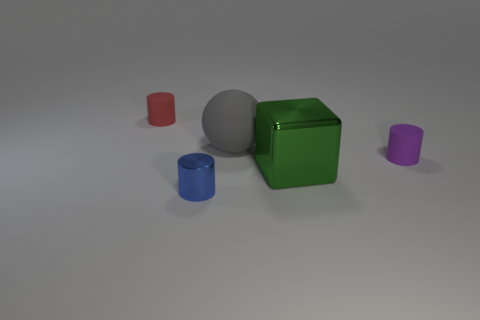The red rubber cylinder has what size?
Offer a very short reply. Small. The small object that is both in front of the big matte object and on the left side of the block has what shape?
Provide a succinct answer. Cylinder. What color is the other tiny rubber thing that is the same shape as the purple thing?
Your answer should be compact. Red. What number of objects are objects that are left of the green cube or cylinders to the left of the tiny blue thing?
Offer a terse response. 3. The tiny purple matte object has what shape?
Keep it short and to the point. Cylinder. How many big gray things are made of the same material as the red cylinder?
Your answer should be compact. 1. What color is the matte sphere?
Give a very brief answer. Gray. There is another object that is the same size as the green thing; what color is it?
Ensure brevity in your answer.  Gray. There is a small matte thing on the left side of the tiny blue metal cylinder; does it have the same shape as the large thing that is to the left of the metallic block?
Provide a short and direct response. No. What number of other things are the same size as the purple rubber cylinder?
Offer a very short reply. 2. 